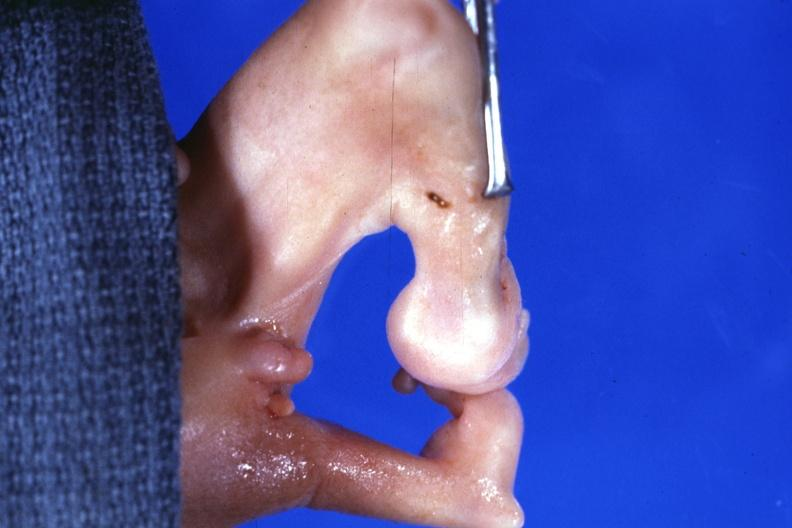re extremities present?
Answer the question using a single word or phrase. Yes 